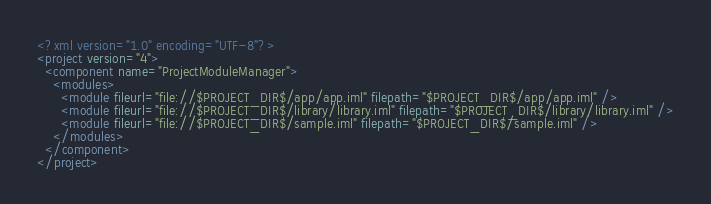<code> <loc_0><loc_0><loc_500><loc_500><_XML_><?xml version="1.0" encoding="UTF-8"?>
<project version="4">
  <component name="ProjectModuleManager">
    <modules>
      <module fileurl="file://$PROJECT_DIR$/app/app.iml" filepath="$PROJECT_DIR$/app/app.iml" />
      <module fileurl="file://$PROJECT_DIR$/library/library.iml" filepath="$PROJECT_DIR$/library/library.iml" />
      <module fileurl="file://$PROJECT_DIR$/sample.iml" filepath="$PROJECT_DIR$/sample.iml" />
    </modules>
  </component>
</project></code> 